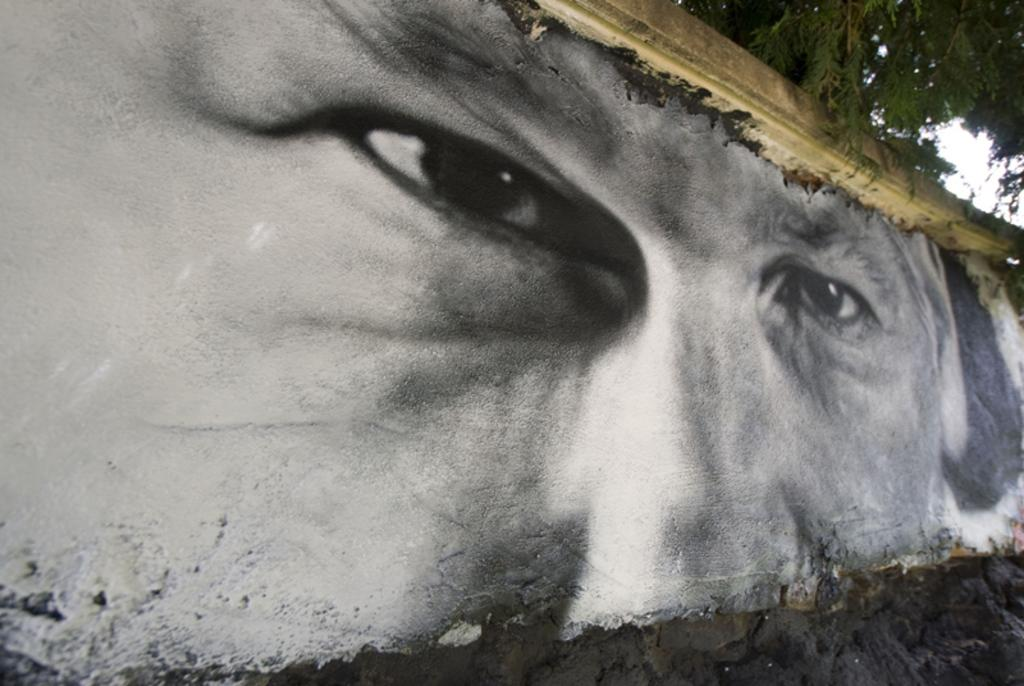What is present on the wall in the image? There is a painting of a man's eyes and nose on the wall. What can be seen behind the wall in the image? There is a tree behind the wall. How many rabbits are playing chess on the wall in the image? There are no rabbits or chess game present in the image. 